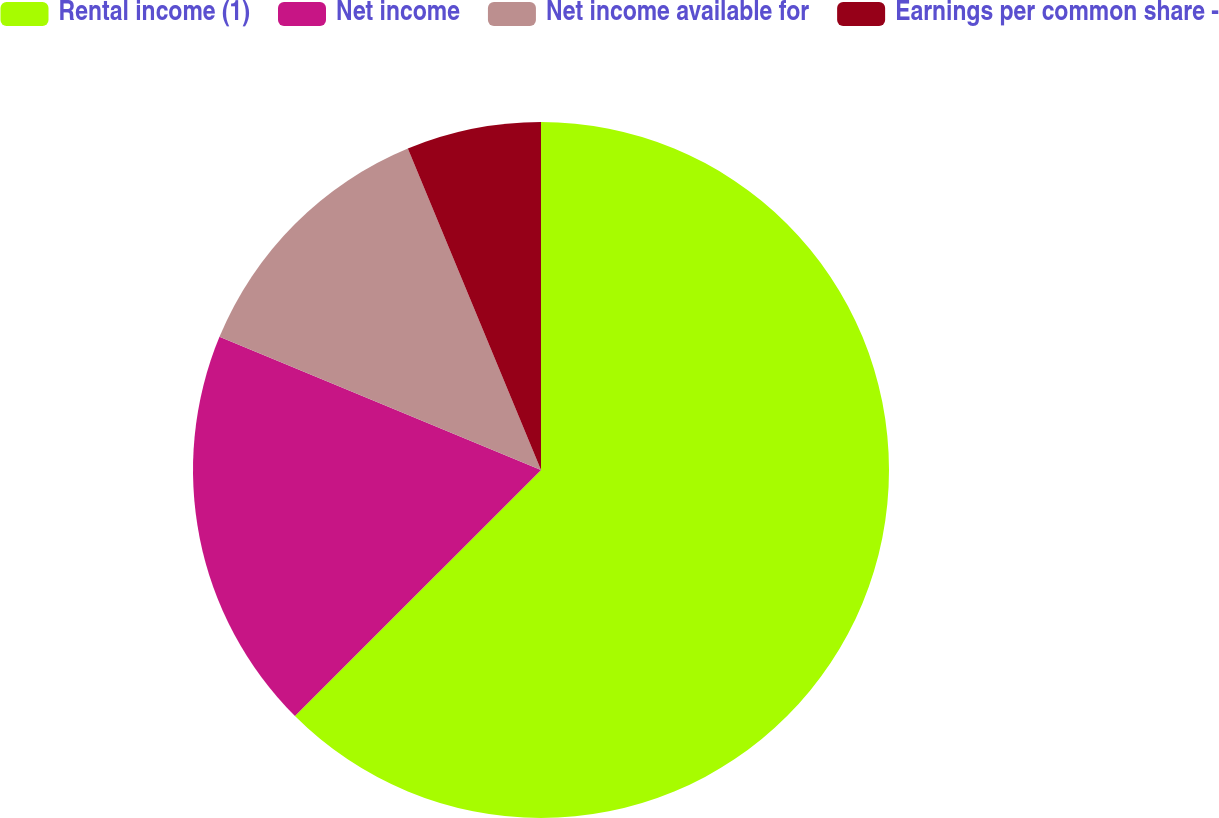Convert chart to OTSL. <chart><loc_0><loc_0><loc_500><loc_500><pie_chart><fcel>Rental income (1)<fcel>Net income<fcel>Net income available for<fcel>Earnings per common share -<nl><fcel>62.5%<fcel>18.75%<fcel>12.5%<fcel>6.25%<nl></chart> 